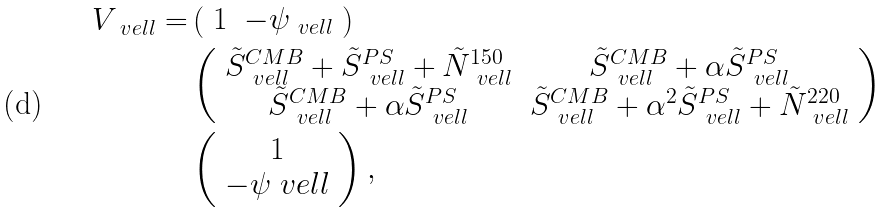Convert formula to latex. <formula><loc_0><loc_0><loc_500><loc_500>V _ { \ v e l l } = & \left ( \begin{array} { c c } 1 & - \psi _ { \ v e l l } \end{array} \right ) \\ & \left ( \begin{array} { c c } \tilde { S } ^ { C M B } _ { \ v e l l } + \tilde { S } ^ { P S } _ { \ v e l l } + \tilde { N } ^ { 1 5 0 } _ { \ v e l l } & \tilde { S } ^ { C M B } _ { \ v e l l } + \alpha \tilde { S } ^ { P S } _ { \ v e l l } \\ \tilde { S } ^ { C M B } _ { \ v e l l } + \alpha \tilde { S } ^ { P S } _ { \ v e l l } & \tilde { S } ^ { C M B } _ { \ v e l l } + \alpha ^ { 2 } \tilde { S } ^ { P S } _ { \ v e l l } + \tilde { N } ^ { 2 2 0 } _ { \ v e l l } \end{array} \right ) \\ & \left ( \begin{array} { c } 1 \\ - \psi _ { \ } v e l l \end{array} \right ) ,</formula> 